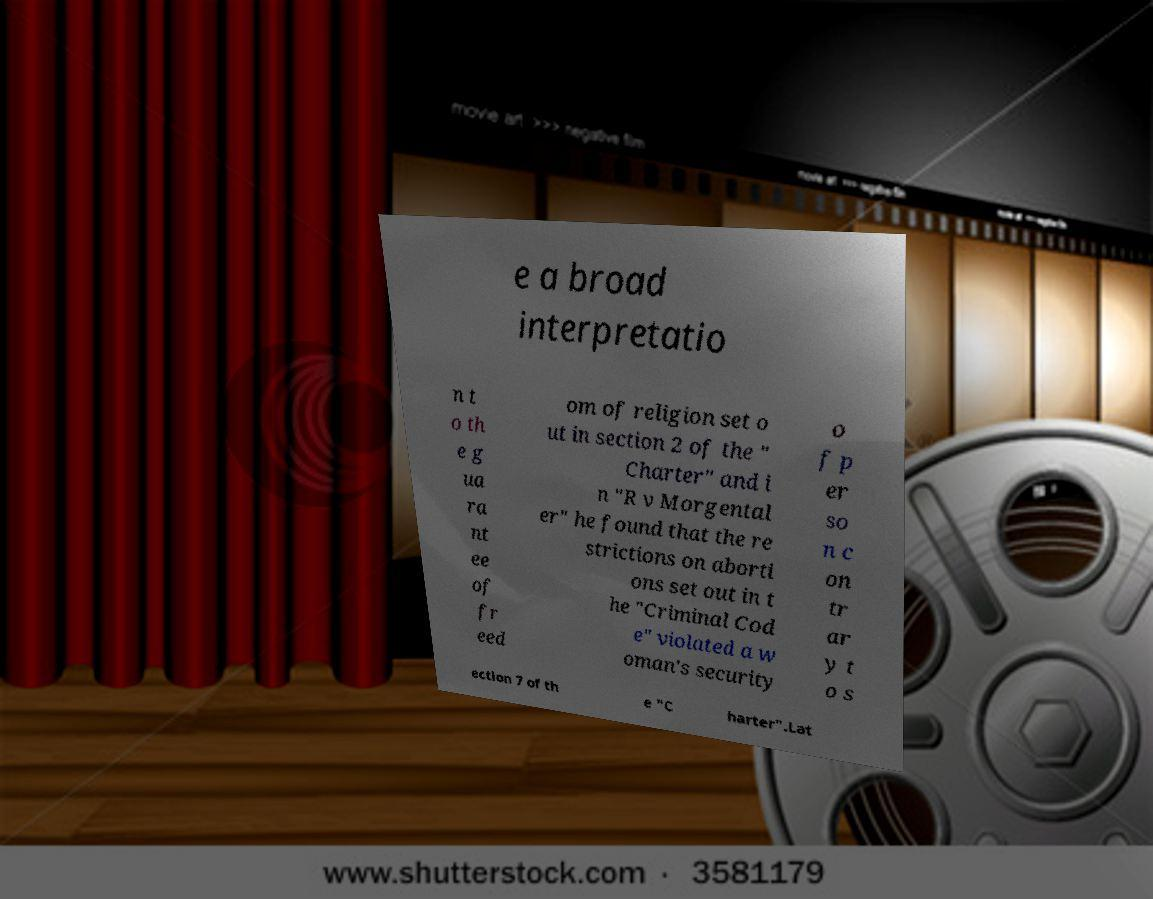Please identify and transcribe the text found in this image. e a broad interpretatio n t o th e g ua ra nt ee of fr eed om of religion set o ut in section 2 of the " Charter" and i n "R v Morgental er" he found that the re strictions on aborti ons set out in t he "Criminal Cod e" violated a w oman's security o f p er so n c on tr ar y t o s ection 7 of th e "C harter".Lat 